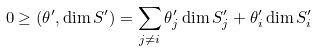Convert formula to latex. <formula><loc_0><loc_0><loc_500><loc_500>0 \geq ( \theta ^ { \prime } , \dim S ^ { \prime } ) = \sum _ { j \neq i } \theta ^ { \prime } _ { j } \dim S ^ { \prime } _ { j } + \theta ^ { \prime } _ { i } \dim S ^ { \prime } _ { i }</formula> 